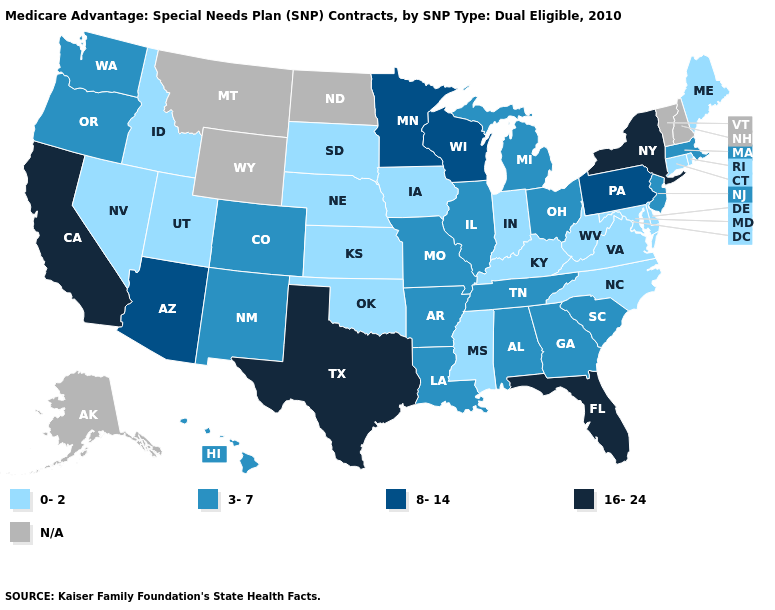Name the states that have a value in the range 0-2?
Answer briefly. Connecticut, Delaware, Iowa, Idaho, Indiana, Kansas, Kentucky, Maryland, Maine, Mississippi, North Carolina, Nebraska, Nevada, Oklahoma, Rhode Island, South Dakota, Utah, Virginia, West Virginia. What is the highest value in the MidWest ?
Quick response, please. 8-14. What is the lowest value in states that border Minnesota?
Give a very brief answer. 0-2. Name the states that have a value in the range N/A?
Short answer required. Alaska, Montana, North Dakota, New Hampshire, Vermont, Wyoming. What is the lowest value in the West?
Quick response, please. 0-2. Name the states that have a value in the range N/A?
Answer briefly. Alaska, Montana, North Dakota, New Hampshire, Vermont, Wyoming. Name the states that have a value in the range N/A?
Answer briefly. Alaska, Montana, North Dakota, New Hampshire, Vermont, Wyoming. Does California have the highest value in the USA?
Give a very brief answer. Yes. What is the value of Georgia?
Keep it brief. 3-7. Which states have the lowest value in the West?
Concise answer only. Idaho, Nevada, Utah. What is the lowest value in states that border Oklahoma?
Give a very brief answer. 0-2. Does Connecticut have the highest value in the USA?
Concise answer only. No. Name the states that have a value in the range 0-2?
Keep it brief. Connecticut, Delaware, Iowa, Idaho, Indiana, Kansas, Kentucky, Maryland, Maine, Mississippi, North Carolina, Nebraska, Nevada, Oklahoma, Rhode Island, South Dakota, Utah, Virginia, West Virginia. Among the states that border Idaho , which have the lowest value?
Keep it brief. Nevada, Utah. Does Oklahoma have the lowest value in the USA?
Concise answer only. Yes. 